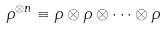<formula> <loc_0><loc_0><loc_500><loc_500>\rho ^ { \otimes n } \equiv \rho \otimes \rho \otimes \cdots \otimes \rho</formula> 